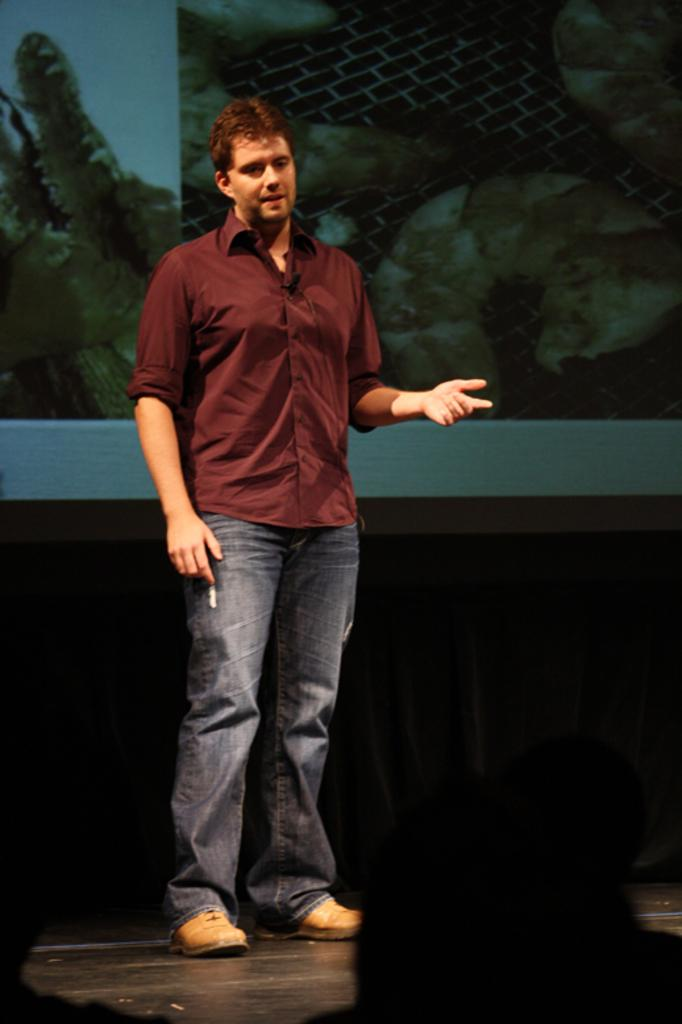What is the main subject of the image? There is a man standing in the image. What can be seen in the background of the image? There is a screen in the background of the image. Are there any other people visible in the image? Yes, there are people visible at the bottom of the image. What type of juice is being squeezed by the man in the image? There is no juice or squeezing action present in the image; the man is simply standing. 